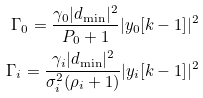<formula> <loc_0><loc_0><loc_500><loc_500>\Gamma _ { 0 } = \frac { \gamma _ { 0 } | d _ { \min } | ^ { 2 } } { P _ { 0 } + 1 } | y _ { 0 } [ k - 1 ] | ^ { 2 } \\ \Gamma _ { i } = \frac { \gamma _ { i } | d _ { \min } | ^ { 2 } } { \sigma _ { i } ^ { 2 } ( \rho _ { i } + 1 ) } | y _ { i } [ k - 1 ] | ^ { 2 }</formula> 